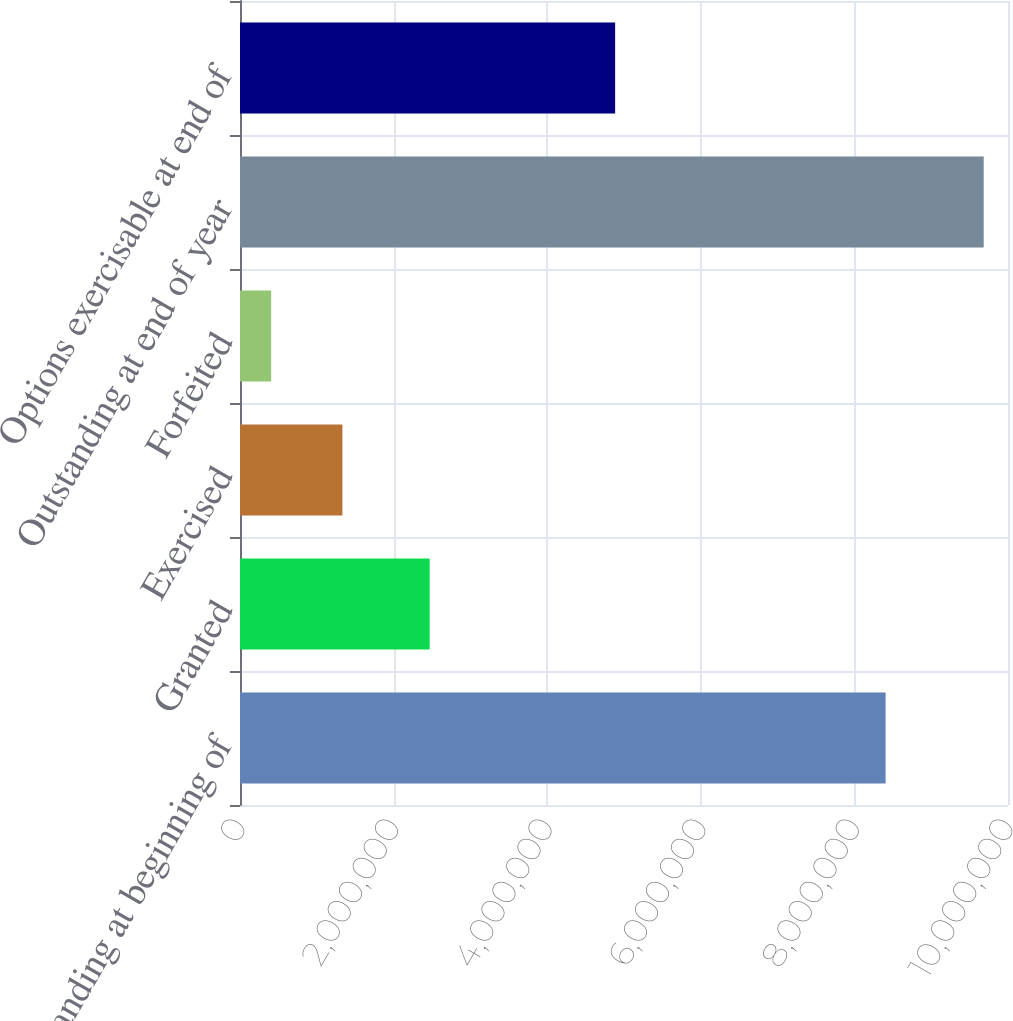<chart> <loc_0><loc_0><loc_500><loc_500><bar_chart><fcel>Outstanding at beginning of<fcel>Granted<fcel>Exercised<fcel>Forfeited<fcel>Outstanding at end of year<fcel>Options exercisable at end of<nl><fcel>8.40648e+06<fcel>2.46965e+06<fcel>1.3336e+06<fcel>405794<fcel>9.68382e+06<fcel>4.88448e+06<nl></chart> 